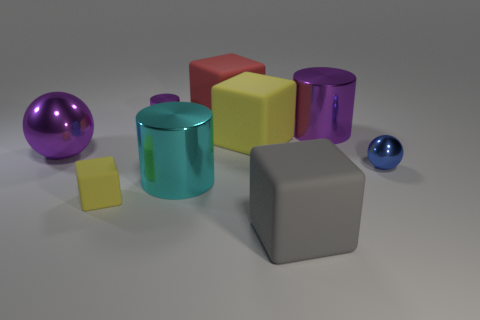Add 1 tiny purple metal things. How many objects exist? 10 Subtract all cylinders. How many objects are left? 6 Subtract all large cubes. Subtract all small metallic balls. How many objects are left? 5 Add 9 big yellow objects. How many big yellow objects are left? 10 Add 7 small brown blocks. How many small brown blocks exist? 7 Subtract 0 gray cylinders. How many objects are left? 9 